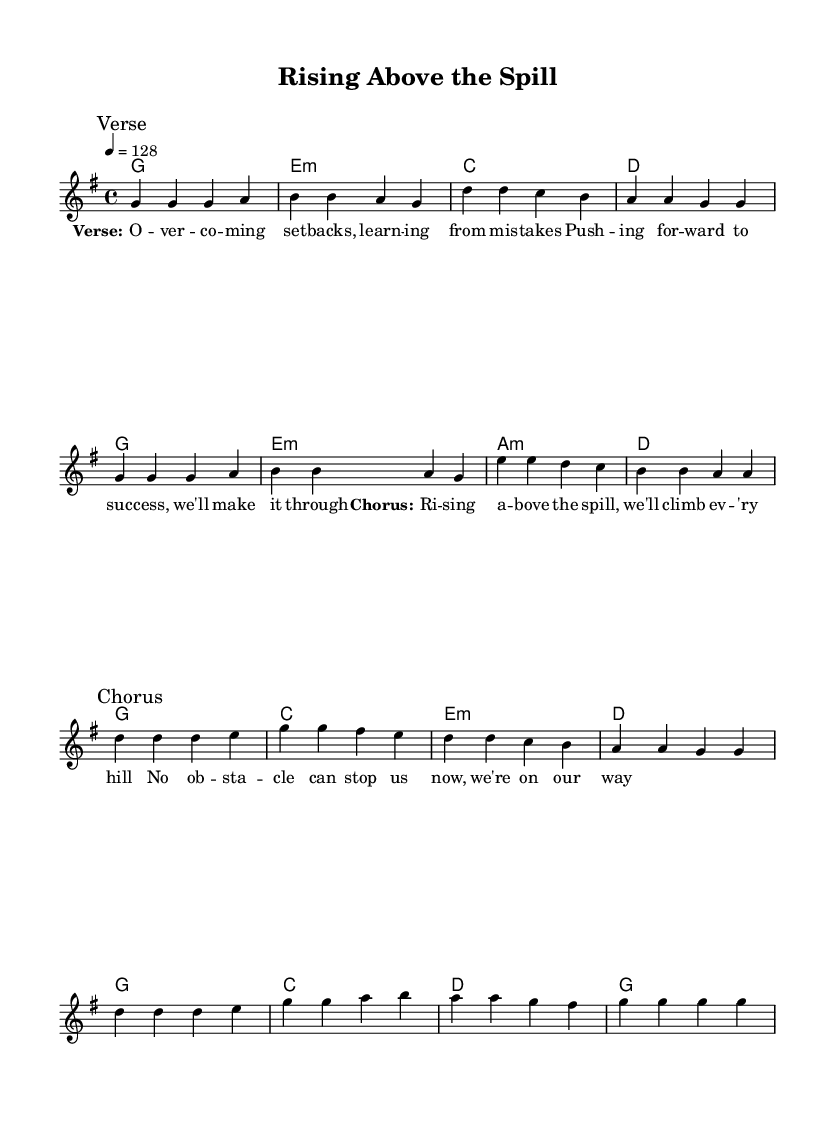What is the key signature of this music? The key signature is G major, which has one sharp (F#). This can be identified by looking at the key signature at the beginning of the staff.
Answer: G major What is the time signature of this music? The time signature is 4/4, indicated by the numbers at the beginning of the score. This means there are four beats per measure and the quarter note gets one beat.
Answer: 4/4 What is the tempo marking of this piece? The tempo is marked as 128 beats per minute, which is indicated in the score at the beginning of the global section. This shows how fast the piece should be played.
Answer: 128 How many measures are in the verse section? The verse section has eight measures, which can be counted by tallying the bars in the verse segment of the melody.
Answer: Eight How many chords are in the harmony section? There are twelve chords listed in the harmony section when counted sequentially from the chordmode.
Answer: Twelve What is the primary theme expressed in the lyrics? The primary theme is perseverance and overcoming obstacles, which is conveyed through the lyrics that focus on pushing forward despite challenges.
Answer: Perseverance What K-Pop stylistic elements are present in this music? The music includes a strong, repetitive chorus structure and uplifting lyrics, both characteristic of K-Pop anthems that focus on motivation and encouragement.
Answer: Uplifting elements 